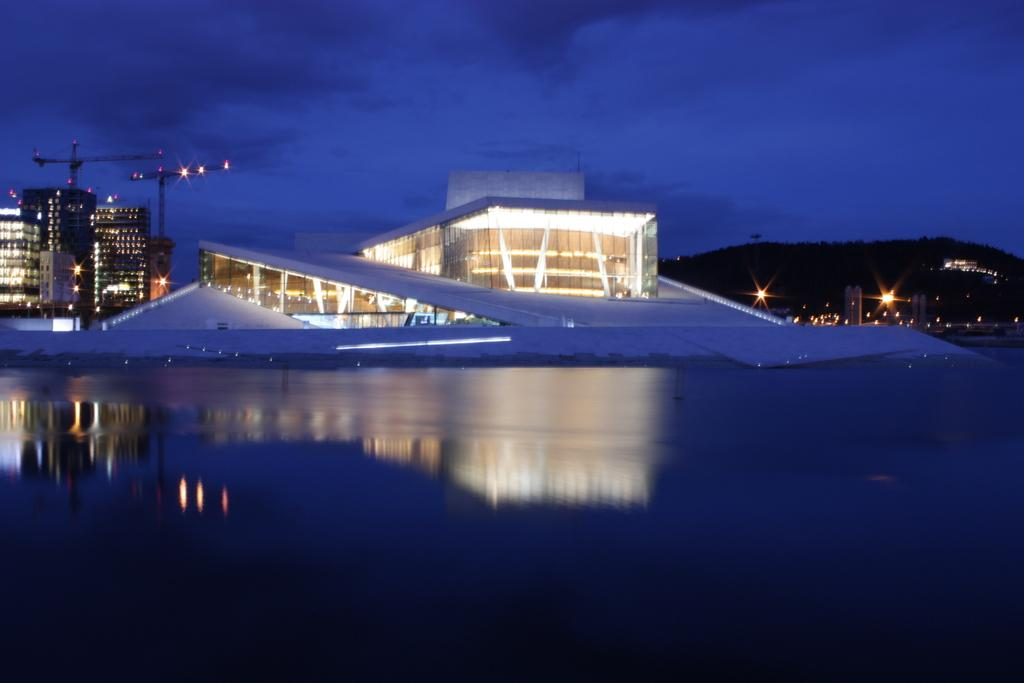What is at the bottom of the image? There is water at the bottom of the image. What can be seen in the distance in the image? There are buildings and a mountain in the background of the image. How are the buildings illuminated in the image? The buildings have lighting. What is visible in the sky in the image? There are clouds in the sky. How does the loss of stem affect the growth of the buildings in the image? There is no mention of stem or growth in the image, as it features water, buildings, a mountain, and clouds. 